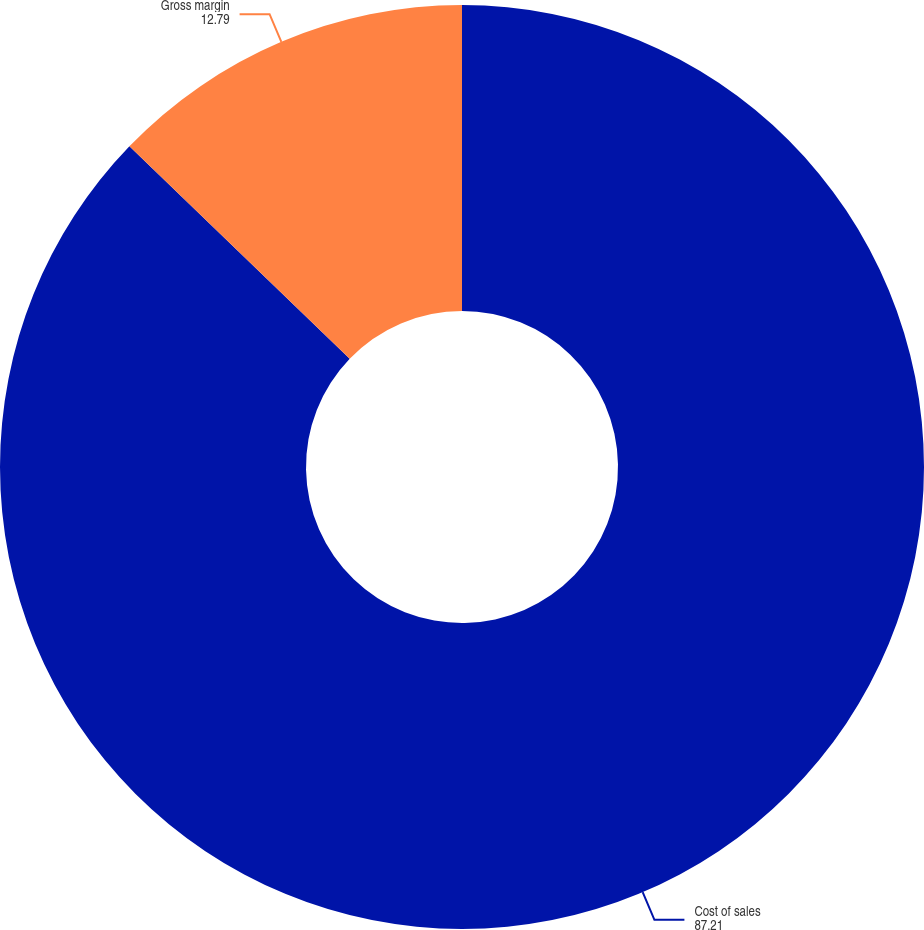Convert chart to OTSL. <chart><loc_0><loc_0><loc_500><loc_500><pie_chart><fcel>Cost of sales<fcel>Gross margin<nl><fcel>87.21%<fcel>12.79%<nl></chart> 